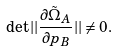<formula> <loc_0><loc_0><loc_500><loc_500>\det | | \frac { \partial { \tilde { \Omega } } _ { A } } { \partial p _ { B } } | | \ne 0 .</formula> 